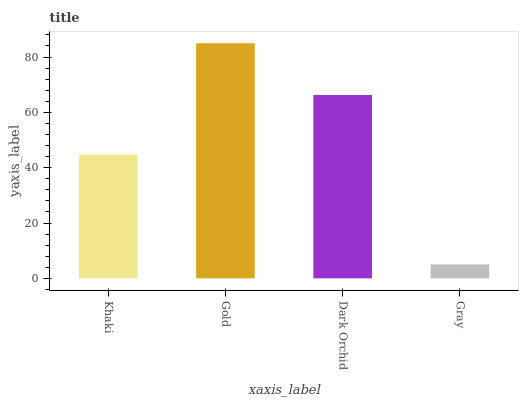Is Gray the minimum?
Answer yes or no. Yes. Is Gold the maximum?
Answer yes or no. Yes. Is Dark Orchid the minimum?
Answer yes or no. No. Is Dark Orchid the maximum?
Answer yes or no. No. Is Gold greater than Dark Orchid?
Answer yes or no. Yes. Is Dark Orchid less than Gold?
Answer yes or no. Yes. Is Dark Orchid greater than Gold?
Answer yes or no. No. Is Gold less than Dark Orchid?
Answer yes or no. No. Is Dark Orchid the high median?
Answer yes or no. Yes. Is Khaki the low median?
Answer yes or no. Yes. Is Khaki the high median?
Answer yes or no. No. Is Gray the low median?
Answer yes or no. No. 